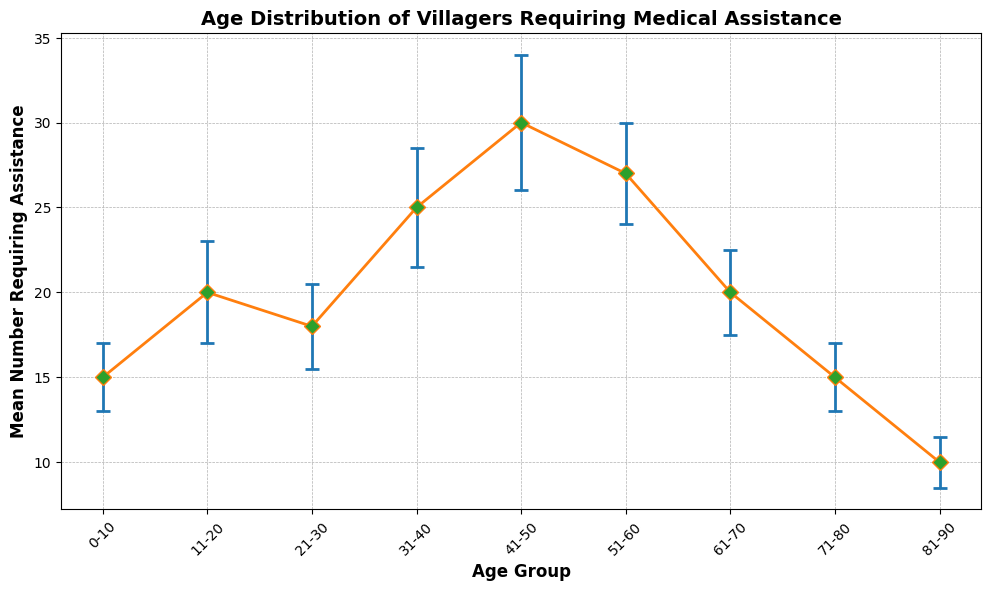What is the age group with the highest mean number of villagers requiring assistance? The group 41-50 has the highest bar in the chart, representing the highest mean value.
Answer: 41-50 Which age group has the smallest uncertainty in the number of villagers requiring assistance? The group 81-90 has the shortest error bar, indicating the smallest uncertainty.
Answer: 81-90 How much higher is the mean number of villagers requiring assistance in the age group 41-50 compared to the age group 0-10? The mean for 41-50 is 30 and for 0-10 is 15. Subtract to find the difference: 30 - 15 = 15.
Answer: 15 What is the range of the mean number of villagers requiring assistance for all age groups? The highest mean is 30 (41-50) and the lowest mean is 10 (81-90), giving a range of 30 - 10 = 20.
Answer: 20 What is the combined mean number of villagers requiring assistance for the age groups 61-70 and 71-80? Sum the means for 61-70 (20) and 71-80 (15): 20 + 15 = 35.
Answer: 35 Which age group has a mean number of villagers requiring assistance that is equal to the mean for the age group 71-80? The age group 0-10 also has a mean of 15, the same as 71-80.
Answer: 0-10 How much is the uncertainty (standard deviation) for the age group 31-40 compared to the 51-60 group? The standard deviation for 31-40 is 3.5 and for 51-60 is 3. Subtract to get the difference: 3.5 - 3 = 0.5.
Answer: 0.5 If we average the mean number of villagers requiring assistance across all age groups, what is the mean value? Sum the mean values: 15 + 20 + 18 + 25 + 30 + 27 + 20 + 15 + 10 = 180. Divide by the number of groups, 9: 180 / 9 = 20.
Answer: 20 